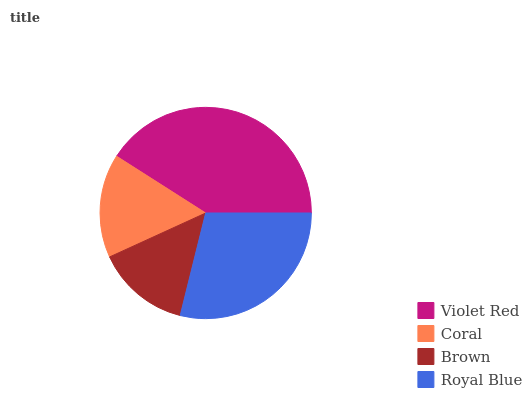Is Brown the minimum?
Answer yes or no. Yes. Is Violet Red the maximum?
Answer yes or no. Yes. Is Coral the minimum?
Answer yes or no. No. Is Coral the maximum?
Answer yes or no. No. Is Violet Red greater than Coral?
Answer yes or no. Yes. Is Coral less than Violet Red?
Answer yes or no. Yes. Is Coral greater than Violet Red?
Answer yes or no. No. Is Violet Red less than Coral?
Answer yes or no. No. Is Royal Blue the high median?
Answer yes or no. Yes. Is Coral the low median?
Answer yes or no. Yes. Is Violet Red the high median?
Answer yes or no. No. Is Brown the low median?
Answer yes or no. No. 